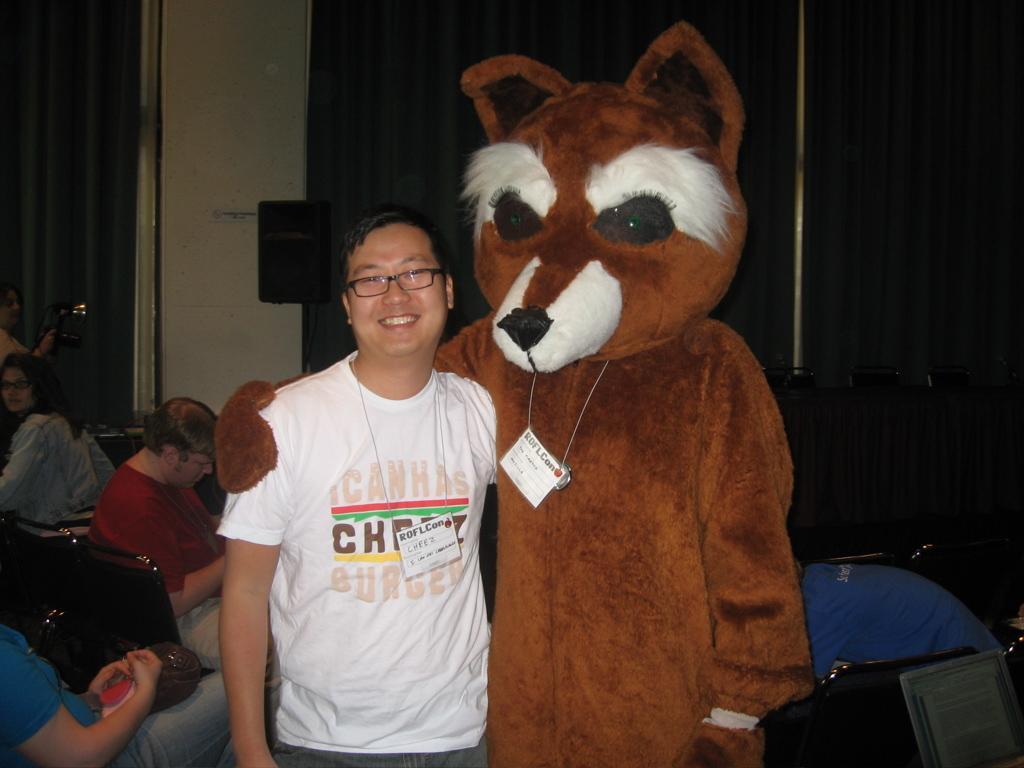Describe this image in one or two sentences. The man in the middle of the picture wearing white T-shirt and spectacles is standing. He is smiling. Beside him, we see a person wearing mascot costume is standing. Behind them, we see people sitting on the floor. In the background, we see a white wall and a black cupboard. 